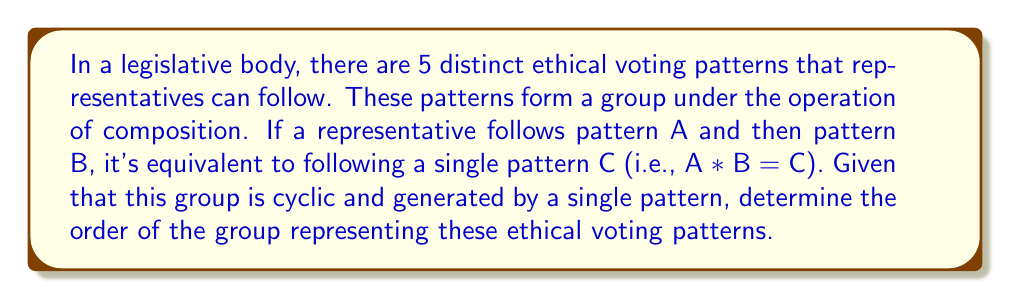Give your solution to this math problem. To solve this problem, we need to consider the properties of cyclic groups:

1) A cyclic group is generated by a single element, called the generator.

2) The order of a cyclic group is equal to the order of its generator.

3) In a finite cyclic group of order n, the possible orders of elements are the divisors of n.

Given that there are 5 distinct patterns, and the group is cyclic, we can deduce:

a) The order of the group must be at least 5 to accommodate all distinct patterns.

b) Since 5 is a prime number, the only divisors of 5 are 1 and 5.

c) If the order of the group were larger than 5, say 10, then there would be elements of order 2 and elements of order 5, resulting in more than 5 distinct patterns.

Therefore, the only possible order for this group is 5.

In group theory notation:

Let $G$ be the group of ethical voting patterns, and $a$ be the generator of $G$.

Then, $G = \langle a \rangle = \{e, a, a^2, a^3, a^4\}$, where $e$ is the identity element (representing no change in voting pattern), and $a^5 = e$.

The order of the group is given by $|G| = |\langle a \rangle| = 5$.
Answer: The order of the group representing ethical voting patterns is 5. 